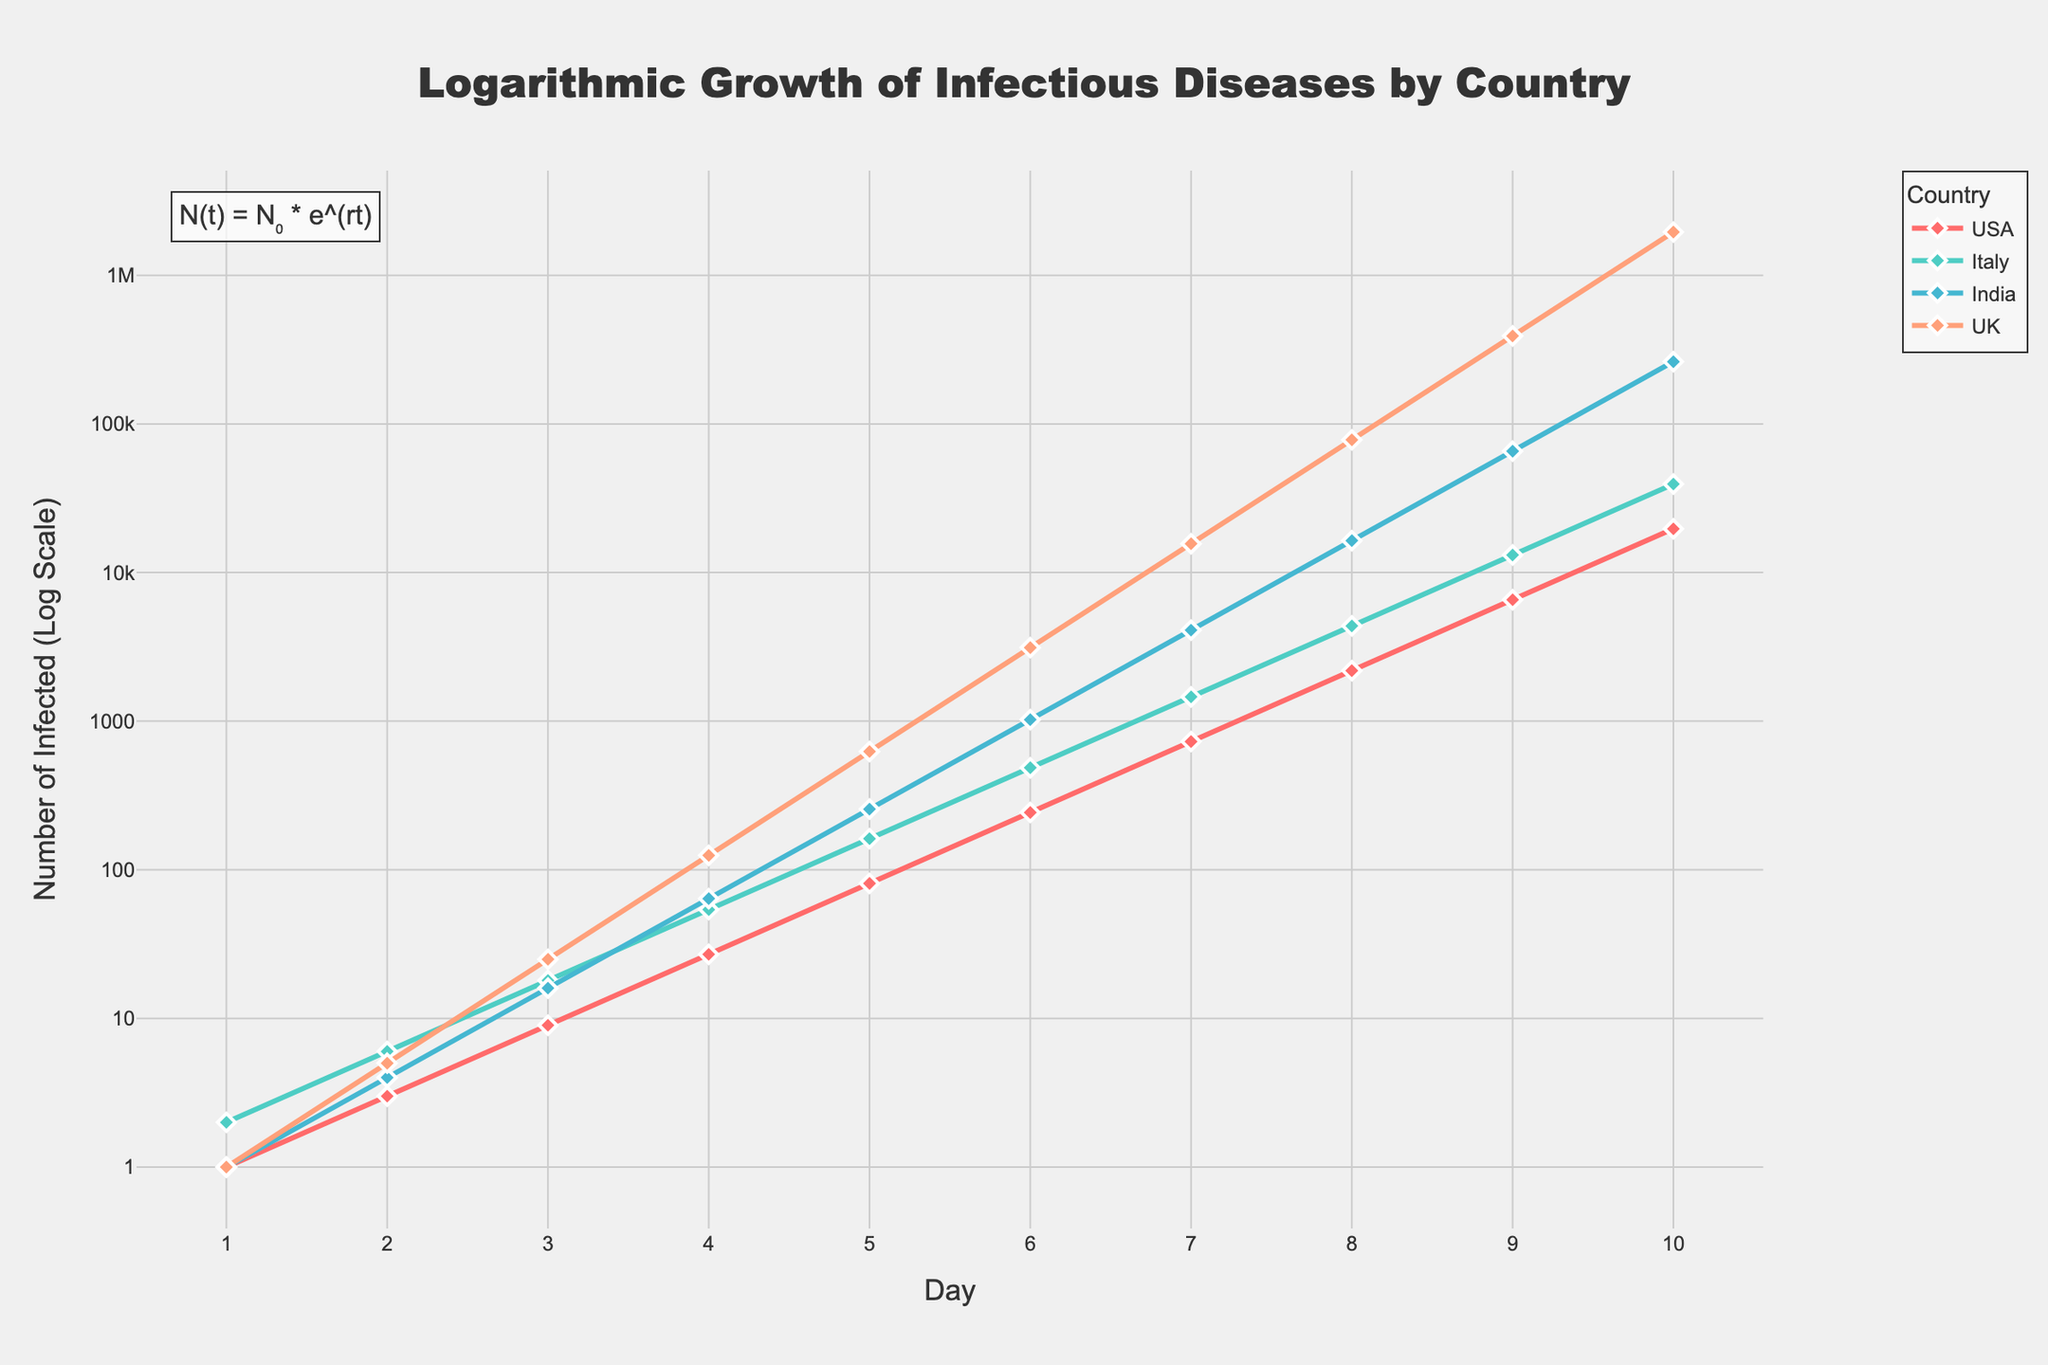What's the title of the plot? The title is at the top center of the figure and provides a summary of what the figure represents. In this case, it is "Logarithmic Growth of Infectious Diseases by Country."
Answer: Logarithmic Growth of Infectious Diseases by Country What is the y-axis title? The y-axis title describes the type of data being displayed on the y-axis. Here, it is "Number of Infected (Log Scale)."
Answer: Number of Infected (Log Scale) How many countries are represented in the plot? The plot has a legend that lists all the countries represented in the plot. According to the legend, there are four countries: USA, Italy, India, and UK.
Answer: Four Which country had the highest number of infected persons on Day 10? By examining the end of each line graph on Day 10, the UK shows the highest number of infected persons. The y-axis value for the UK on Day 10 is the highest.
Answer: UK Compare the growth rates of infections for the USA and India between Day 4 and Day 7. To compare the growth rates, observe the slopes of the lines for USA and India between Day 4 and Day 7. The slope for India is steeper than for the USA, indicating a faster infection growth rate in India during this period.
Answer: India has a faster growth rate By what factor did the infected numbers increase in Italy from Day 3 to Day 6? In Italy, the number of infected people on Day 3 is 18, and on Day 6 is 486. The factor of increase can be calculated as 486/18 = 27.
Answer: 27 What is the mathematical formula annotated on the plot, and what does it represent? The annotation on the plot shows "N(t) = N₀ * e^(rt)," which represents exponential growth. N(t) is the number of infected people at time t, N₀ is the initial number of infected, r is the growth rate, and t is time.
Answer: N(t) = N₀ * e^(rt) Which country's infections showed the smallest increase from Day 1 to Day 2? By looking at the y-values from Day 1 to Day 2 for each country, USA increased from 1 to 3, Italy from 2 to 6, India from 1 to 4, and UK from 1 to 5. The smallest increase by absolute numbers is from the USA with an increase of 2.
Answer: USA What pattern can be observed in the infection growth curves of all countries? All countries show an exponential growth pattern as seen from their steep upward curves on the logarithmic scale, highlighting rapid increases over time.
Answer: Exponential growth pattern 